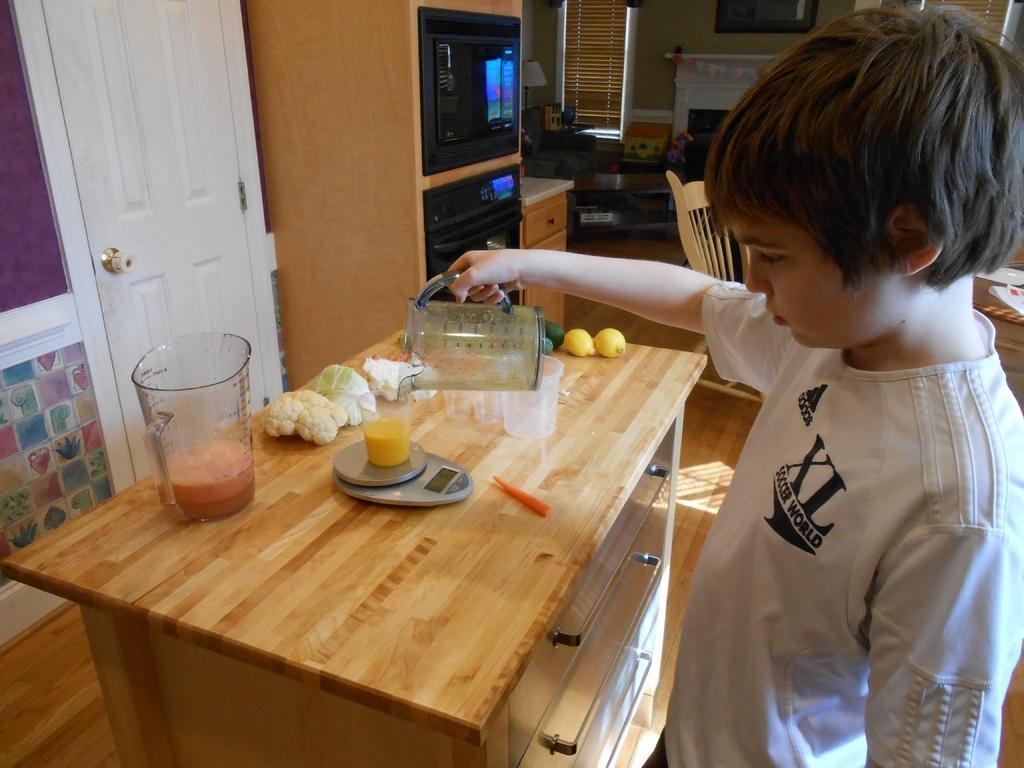Could you give a brief overview of what you see in this image? This is the boy standing and holding the jug. This is the table with jug of juice,vegetables. this is the weighing machine with a jar on it. These are the jars placed on the table. This is the door with door handle. I think this is the micro oven. At background I can see a lamp,teapoy,window covered with curtain. This looks like a fireplace. This is the frame attached to the wall. This is the chair. 